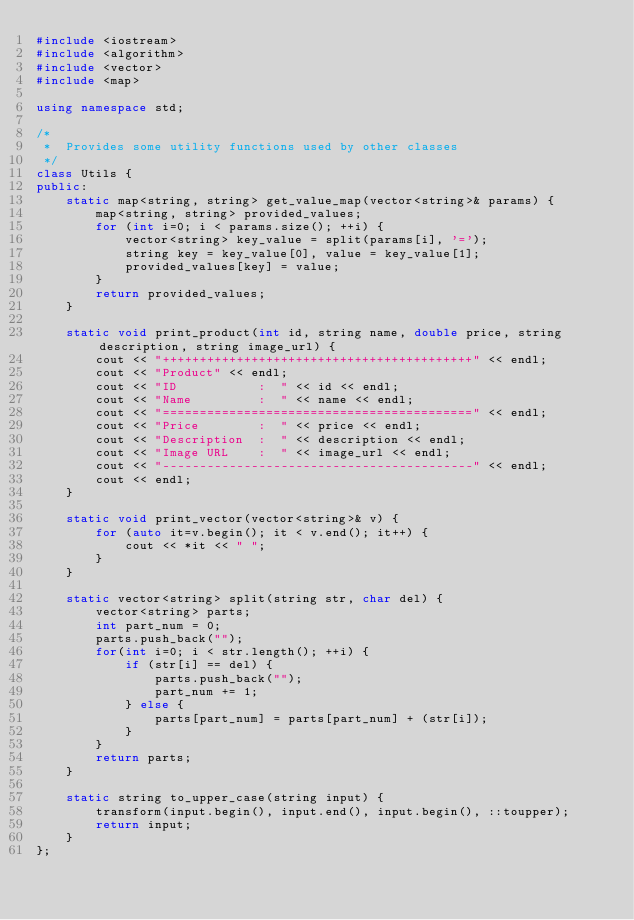Convert code to text. <code><loc_0><loc_0><loc_500><loc_500><_C++_>#include <iostream>
#include <algorithm> 
#include <vector>
#include <map>

using namespace std;

/*
 *  Provides some utility functions used by other classes
 */
class Utils {
public:
    static map<string, string> get_value_map(vector<string>& params) {
        map<string, string> provided_values;
        for (int i=0; i < params.size(); ++i) {
            vector<string> key_value = split(params[i], '=');
            string key = key_value[0], value = key_value[1];
            provided_values[key] = value;
        }
        return provided_values;
    }

    static void print_product(int id, string name, double price, string description, string image_url) {
        cout << "++++++++++++++++++++++++++++++++++++++++++" << endl;
        cout << "Product" << endl;
        cout << "ID           :  " << id << endl;
        cout << "Name         :  " << name << endl;
        cout << "==========================================" << endl;
        cout << "Price        :  " << price << endl;
        cout << "Description  :  " << description << endl;
        cout << "Image URL    :  " << image_url << endl;
        cout << "------------------------------------------" << endl;
        cout << endl;
    }

    static void print_vector(vector<string>& v) {
        for (auto it=v.begin(); it < v.end(); it++) {
            cout << *it << " ";
        }
    }

    static vector<string> split(string str, char del) {
        vector<string> parts;
        int part_num = 0;
        parts.push_back("");
        for(int i=0; i < str.length(); ++i) {
            if (str[i] == del) {
                parts.push_back("");
                part_num += 1;
            } else {
                parts[part_num] = parts[part_num] + (str[i]);
            }
        }
        return parts;
    }

    static string to_upper_case(string input) {
        transform(input.begin(), input.end(), input.begin(), ::toupper);
        return input;
    }
};</code> 